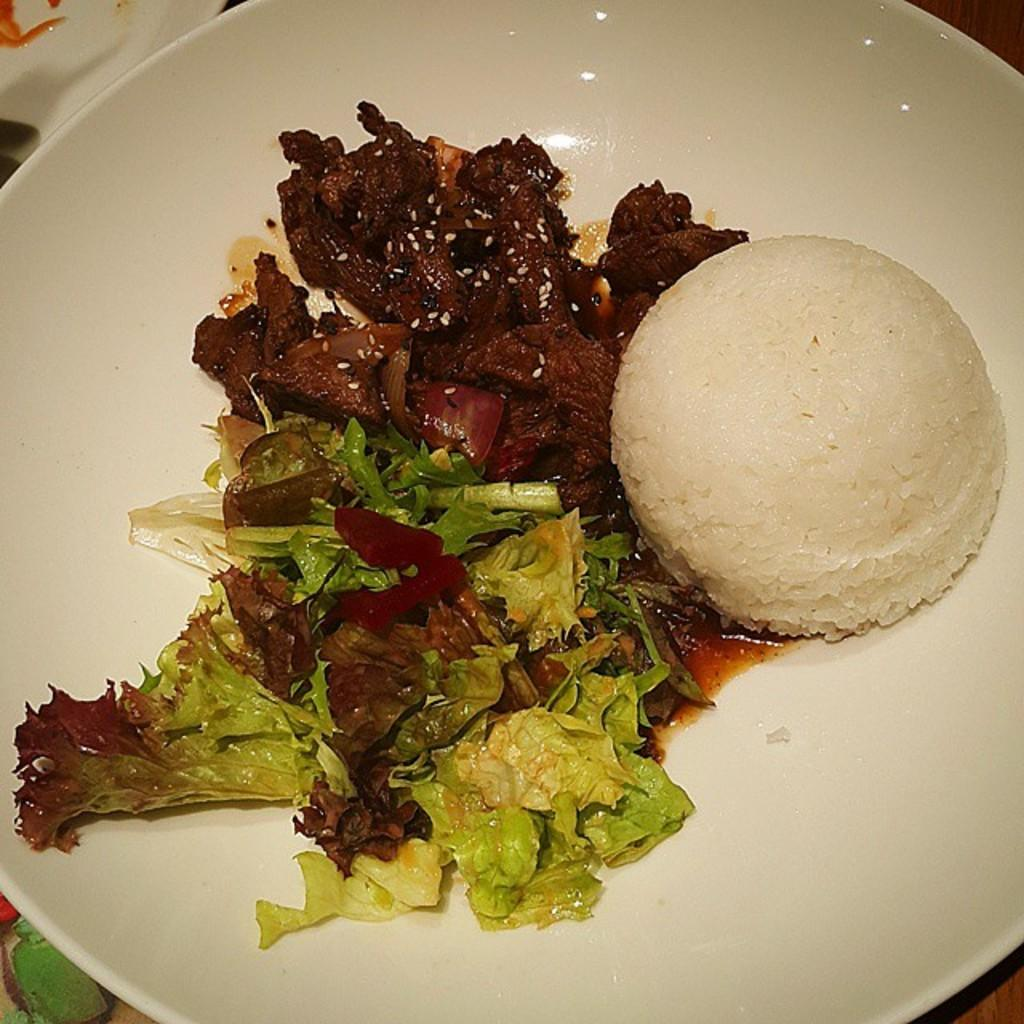What is present on the plate in the image? The plate contains food items. Can you describe the food items on the plate? Unfortunately, the specific food items cannot be determined from the provided facts. How many people are running in the image? There is no information about people running in the image, as it only mentions a plate with food items. What type of vest is visible on the plate? There is no vest present in the image, as it only mentions a plate with food items. 